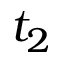Convert formula to latex. <formula><loc_0><loc_0><loc_500><loc_500>t _ { 2 }</formula> 